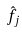Convert formula to latex. <formula><loc_0><loc_0><loc_500><loc_500>\hat { f _ { j } }</formula> 